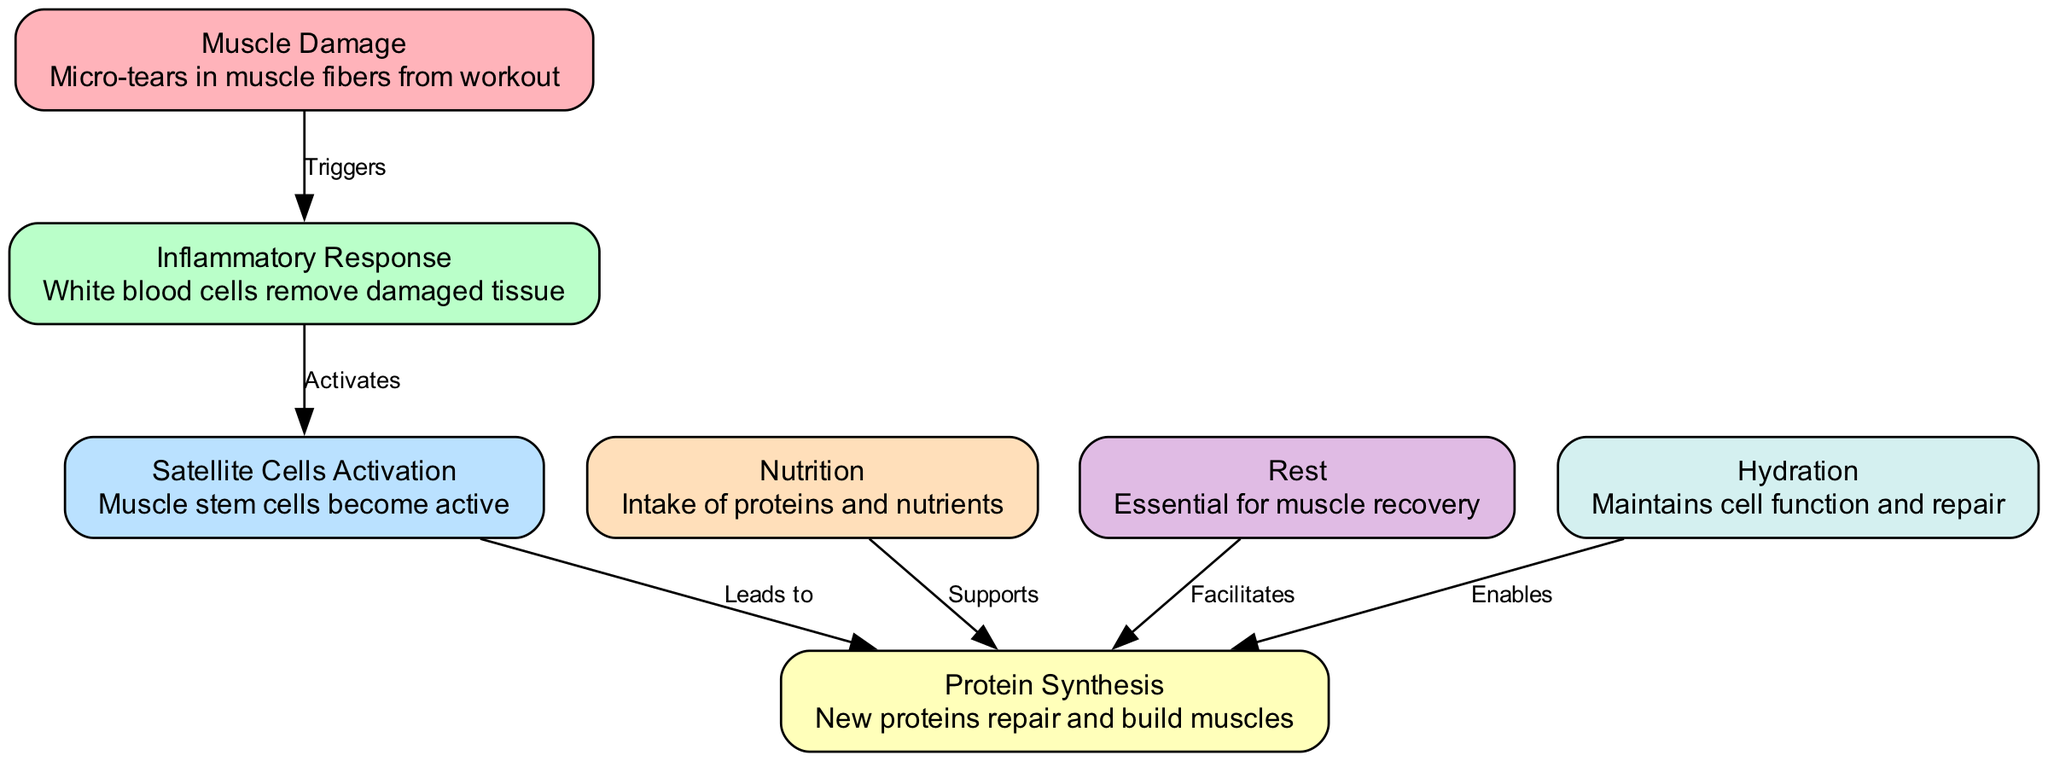What is the first step in the muscle recovery process? According to the diagram, the first step indicated is "Muscle Damage," which represents the micro-tears in muscle fibers resulting from workouts.
Answer: Muscle Damage How many nodes are in the diagram? By counting the distinct entities represented in the diagram, there are a total of seven nodes that illustrate different facets of the muscle recovery process.
Answer: Seven What triggers the inflammatory response? The diagram states that "Muscle Damage" triggers the "Inflammatory Response," indicating a direct causative relationship where damage leads to inflammation.
Answer: Muscle Damage Which process leads to protein synthesis? The diagram shows that "Satellite Cells Activation" directly leads to "Protein Synthesis," highlighting the role of activated muscle stem cells in muscle repair.
Answer: Satellite Cells Activation What role does nutrition play in protein synthesis? According to the diagram, "Nutrition" supports "Protein Synthesis," demonstrating that dietary intake of proteins and nutrients is essential for building new muscle proteins.
Answer: Supports How many processes directly involve protein synthesis? The diagram depicts three processes that directly involve "Protein Synthesis": "Satellite Cells Activation," "Nutrition," and "Rest," which all contribute to the synthesis of new proteins for muscle repair.
Answer: Three What is required to facilitate protein synthesis? The diagram specifies that "Rest" facilitates "Protein Synthesis," signifying the importance of recovery periods for effective muscle repair and growth.
Answer: Rest What maintains cell function and repair in the muscle recovery process? The diagram indicates that "Hydration" enables "Protein Synthesis," showing how proper fluid intake is crucial for maintaining muscle cell function and facilitating recovery.
Answer: Hydration What is the last step in the muscle recovery process? The diagram indicates that "Protein Synthesis" is the final step derived from the earlier processes, ultimately leading to muscle repair and growth.
Answer: Protein Synthesis 